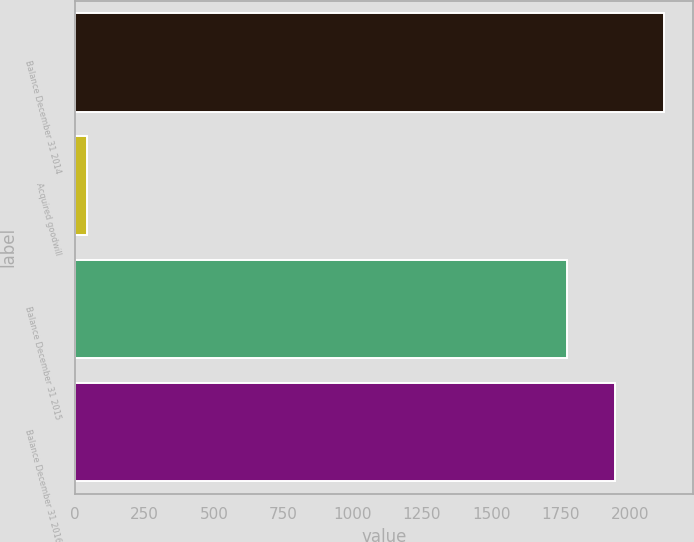<chart> <loc_0><loc_0><loc_500><loc_500><bar_chart><fcel>Balance December 31 2014<fcel>Acquired goodwill<fcel>Balance December 31 2015<fcel>Balance December 31 2016<nl><fcel>2122.6<fcel>42<fcel>1772<fcel>1947.3<nl></chart> 